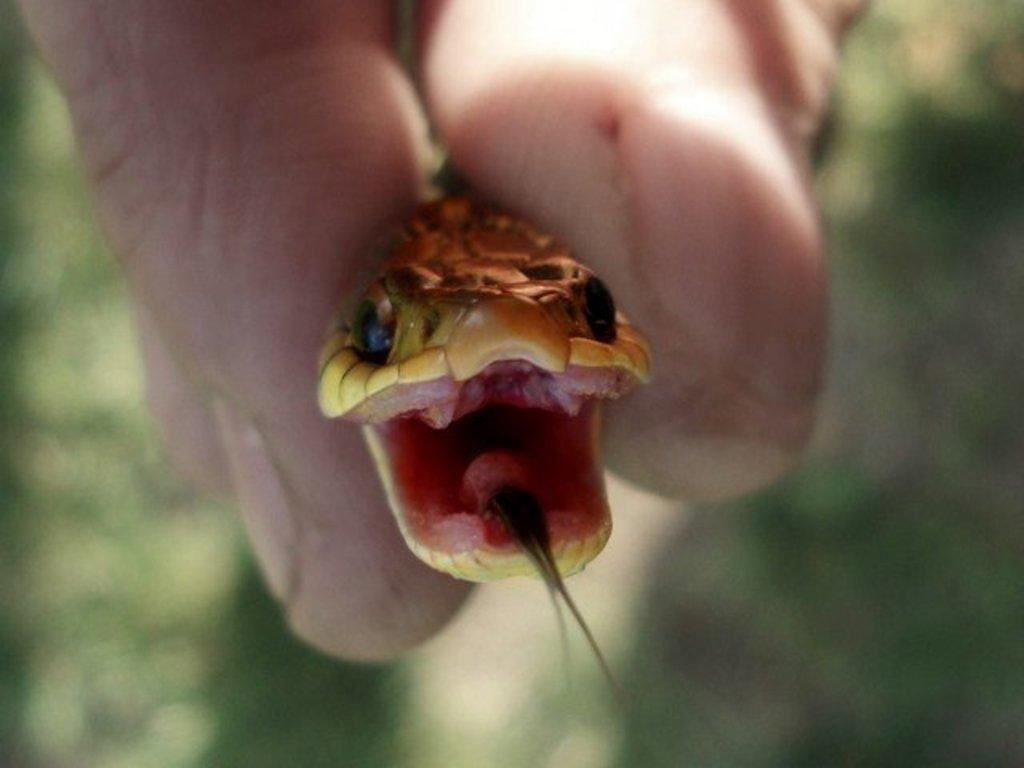Who or what is the main subject in the image? There is a person in the image. What is the person holding in the image? The person is holding a snake. What can be seen in the background of the image? There are trees in the background of the image. How would you describe the background of the image? The background is blurry. What type of growth can be seen on the person's face in the image? There is no growth visible on the person's face in the image. 